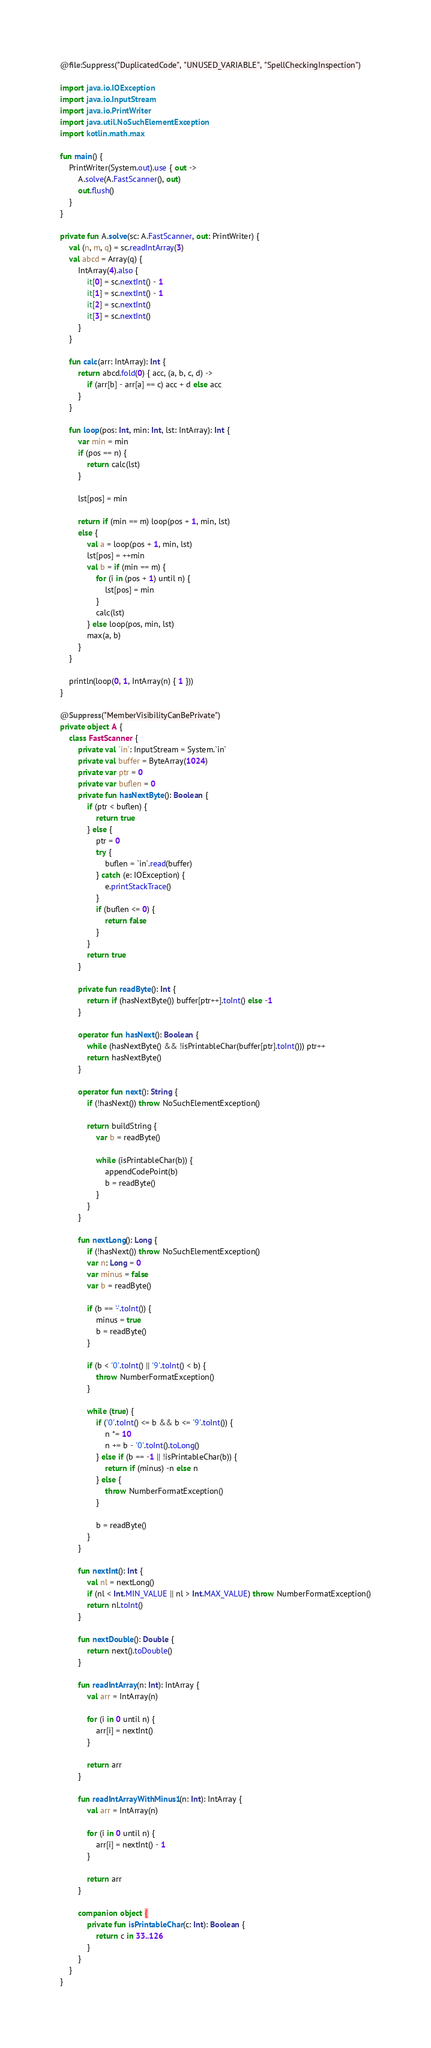<code> <loc_0><loc_0><loc_500><loc_500><_Kotlin_>@file:Suppress("DuplicatedCode", "UNUSED_VARIABLE", "SpellCheckingInspection")

import java.io.IOException
import java.io.InputStream
import java.io.PrintWriter
import java.util.NoSuchElementException
import kotlin.math.max

fun main() {
    PrintWriter(System.out).use { out ->
        A.solve(A.FastScanner(), out)
        out.flush()
    }
}

private fun A.solve(sc: A.FastScanner, out: PrintWriter) {
    val (n, m, q) = sc.readIntArray(3)
    val abcd = Array(q) {
        IntArray(4).also {
            it[0] = sc.nextInt() - 1
            it[1] = sc.nextInt() - 1
            it[2] = sc.nextInt()
            it[3] = sc.nextInt()
        }
    }

    fun calc(arr: IntArray): Int {
        return abcd.fold(0) { acc, (a, b, c, d) ->
            if (arr[b] - arr[a] == c) acc + d else acc
        }
    }

    fun loop(pos: Int, min: Int, lst: IntArray): Int {
        var min = min
        if (pos == n) {
            return calc(lst)
        }

        lst[pos] = min

        return if (min == m) loop(pos + 1, min, lst)
        else {
            val a = loop(pos + 1, min, lst)
            lst[pos] = ++min
            val b = if (min == m) {
                for (i in (pos + 1) until n) {
                    lst[pos] = min
                }
                calc(lst)
            } else loop(pos, min, lst)
            max(a, b)
        }
    }

    println(loop(0, 1, IntArray(n) { 1 }))
}

@Suppress("MemberVisibilityCanBePrivate")
private object A {
    class FastScanner {
        private val `in`: InputStream = System.`in`
        private val buffer = ByteArray(1024)
        private var ptr = 0
        private var buflen = 0
        private fun hasNextByte(): Boolean {
            if (ptr < buflen) {
                return true
            } else {
                ptr = 0
                try {
                    buflen = `in`.read(buffer)
                } catch (e: IOException) {
                    e.printStackTrace()
                }
                if (buflen <= 0) {
                    return false
                }
            }
            return true
        }

        private fun readByte(): Int {
            return if (hasNextByte()) buffer[ptr++].toInt() else -1
        }

        operator fun hasNext(): Boolean {
            while (hasNextByte() && !isPrintableChar(buffer[ptr].toInt())) ptr++
            return hasNextByte()
        }

        operator fun next(): String {
            if (!hasNext()) throw NoSuchElementException()

            return buildString {
                var b = readByte()

                while (isPrintableChar(b)) {
                    appendCodePoint(b)
                    b = readByte()
                }
            }
        }

        fun nextLong(): Long {
            if (!hasNext()) throw NoSuchElementException()
            var n: Long = 0
            var minus = false
            var b = readByte()

            if (b == '-'.toInt()) {
                minus = true
                b = readByte()
            }

            if (b < '0'.toInt() || '9'.toInt() < b) {
                throw NumberFormatException()
            }

            while (true) {
                if ('0'.toInt() <= b && b <= '9'.toInt()) {
                    n *= 10
                    n += b - '0'.toInt().toLong()
                } else if (b == -1 || !isPrintableChar(b)) {
                    return if (minus) -n else n
                } else {
                    throw NumberFormatException()
                }

                b = readByte()
            }
        }

        fun nextInt(): Int {
            val nl = nextLong()
            if (nl < Int.MIN_VALUE || nl > Int.MAX_VALUE) throw NumberFormatException()
            return nl.toInt()
        }

        fun nextDouble(): Double {
            return next().toDouble()
        }

        fun readIntArray(n: Int): IntArray {
            val arr = IntArray(n)

            for (i in 0 until n) {
                arr[i] = nextInt()
            }

            return arr
        }

        fun readIntArrayWithMinus1(n: Int): IntArray {
            val arr = IntArray(n)

            for (i in 0 until n) {
                arr[i] = nextInt() - 1
            }

            return arr
        }

        companion object {
            private fun isPrintableChar(c: Int): Boolean {
                return c in 33..126
            }
        }
    }
}
</code> 